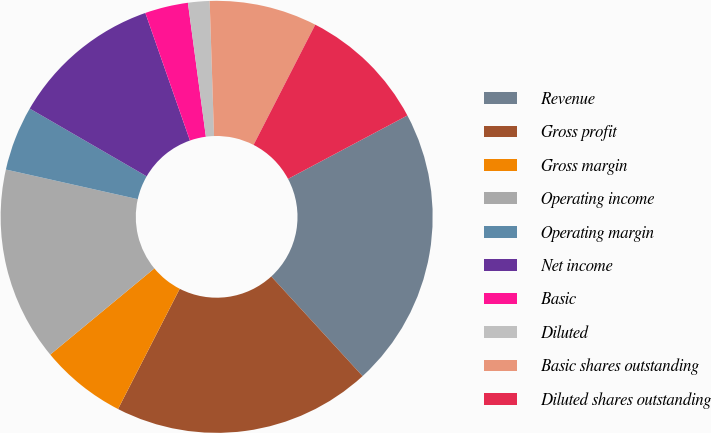Convert chart. <chart><loc_0><loc_0><loc_500><loc_500><pie_chart><fcel>Revenue<fcel>Gross profit<fcel>Gross margin<fcel>Operating income<fcel>Operating margin<fcel>Net income<fcel>Basic<fcel>Diluted<fcel>Basic shares outstanding<fcel>Diluted shares outstanding<nl><fcel>20.97%<fcel>19.35%<fcel>6.45%<fcel>14.52%<fcel>4.84%<fcel>11.29%<fcel>3.23%<fcel>1.61%<fcel>8.06%<fcel>9.68%<nl></chart> 